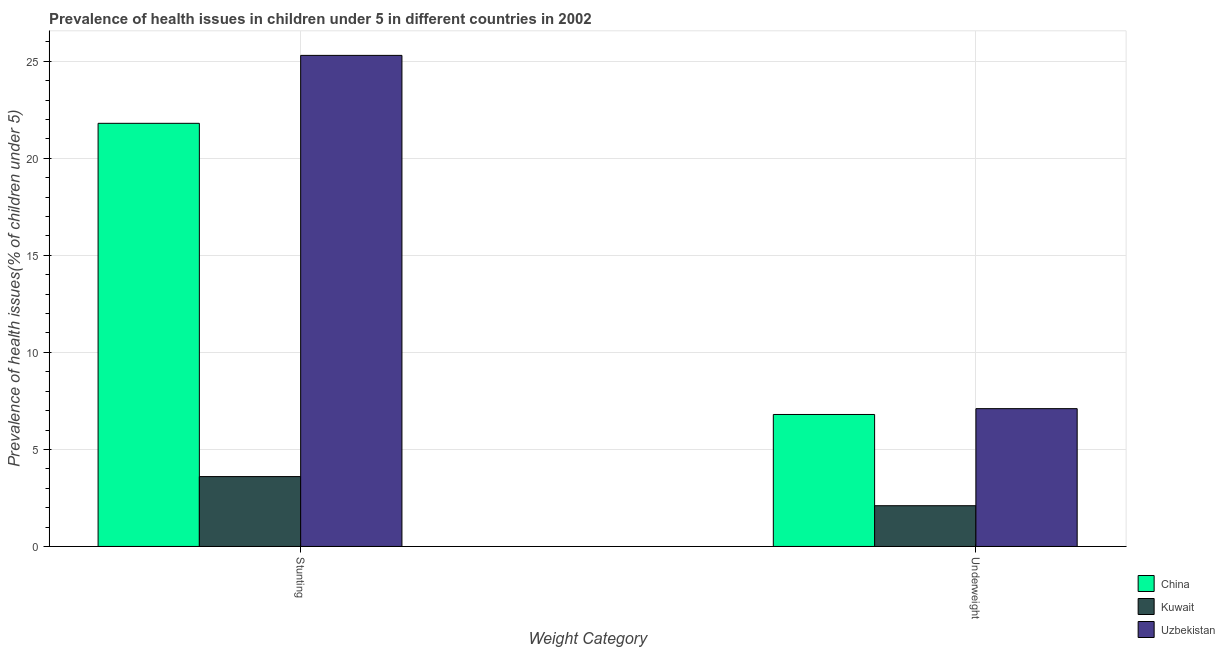Are the number of bars per tick equal to the number of legend labels?
Provide a succinct answer. Yes. Are the number of bars on each tick of the X-axis equal?
Provide a short and direct response. Yes. How many bars are there on the 1st tick from the left?
Offer a terse response. 3. What is the label of the 2nd group of bars from the left?
Keep it short and to the point. Underweight. What is the percentage of stunted children in Uzbekistan?
Your answer should be very brief. 25.3. Across all countries, what is the maximum percentage of underweight children?
Your answer should be compact. 7.1. Across all countries, what is the minimum percentage of underweight children?
Your answer should be very brief. 2.1. In which country was the percentage of stunted children maximum?
Give a very brief answer. Uzbekistan. In which country was the percentage of underweight children minimum?
Offer a terse response. Kuwait. What is the total percentage of stunted children in the graph?
Ensure brevity in your answer.  50.7. What is the difference between the percentage of stunted children in Uzbekistan and the percentage of underweight children in Kuwait?
Your answer should be very brief. 23.2. What is the average percentage of underweight children per country?
Ensure brevity in your answer.  5.33. What is the difference between the percentage of underweight children and percentage of stunted children in China?
Give a very brief answer. -15. In how many countries, is the percentage of stunted children greater than 23 %?
Give a very brief answer. 1. What is the ratio of the percentage of underweight children in Uzbekistan to that in China?
Your response must be concise. 1.04. In how many countries, is the percentage of stunted children greater than the average percentage of stunted children taken over all countries?
Give a very brief answer. 2. What does the 2nd bar from the left in Stunting represents?
Offer a very short reply. Kuwait. What does the 1st bar from the right in Underweight represents?
Offer a terse response. Uzbekistan. How many countries are there in the graph?
Offer a very short reply. 3. What is the difference between two consecutive major ticks on the Y-axis?
Offer a terse response. 5. Are the values on the major ticks of Y-axis written in scientific E-notation?
Offer a very short reply. No. Does the graph contain grids?
Your answer should be very brief. Yes. Where does the legend appear in the graph?
Give a very brief answer. Bottom right. How many legend labels are there?
Your answer should be very brief. 3. How are the legend labels stacked?
Provide a short and direct response. Vertical. What is the title of the graph?
Make the answer very short. Prevalence of health issues in children under 5 in different countries in 2002. Does "Botswana" appear as one of the legend labels in the graph?
Ensure brevity in your answer.  No. What is the label or title of the X-axis?
Keep it short and to the point. Weight Category. What is the label or title of the Y-axis?
Keep it short and to the point. Prevalence of health issues(% of children under 5). What is the Prevalence of health issues(% of children under 5) in China in Stunting?
Provide a succinct answer. 21.8. What is the Prevalence of health issues(% of children under 5) in Kuwait in Stunting?
Give a very brief answer. 3.6. What is the Prevalence of health issues(% of children under 5) in Uzbekistan in Stunting?
Your answer should be very brief. 25.3. What is the Prevalence of health issues(% of children under 5) of China in Underweight?
Provide a succinct answer. 6.8. What is the Prevalence of health issues(% of children under 5) of Kuwait in Underweight?
Offer a terse response. 2.1. What is the Prevalence of health issues(% of children under 5) in Uzbekistan in Underweight?
Offer a terse response. 7.1. Across all Weight Category, what is the maximum Prevalence of health issues(% of children under 5) of China?
Your response must be concise. 21.8. Across all Weight Category, what is the maximum Prevalence of health issues(% of children under 5) in Kuwait?
Offer a very short reply. 3.6. Across all Weight Category, what is the maximum Prevalence of health issues(% of children under 5) in Uzbekistan?
Provide a short and direct response. 25.3. Across all Weight Category, what is the minimum Prevalence of health issues(% of children under 5) in China?
Your answer should be compact. 6.8. Across all Weight Category, what is the minimum Prevalence of health issues(% of children under 5) in Kuwait?
Offer a terse response. 2.1. Across all Weight Category, what is the minimum Prevalence of health issues(% of children under 5) of Uzbekistan?
Your answer should be compact. 7.1. What is the total Prevalence of health issues(% of children under 5) of China in the graph?
Keep it short and to the point. 28.6. What is the total Prevalence of health issues(% of children under 5) in Kuwait in the graph?
Keep it short and to the point. 5.7. What is the total Prevalence of health issues(% of children under 5) in Uzbekistan in the graph?
Provide a succinct answer. 32.4. What is the difference between the Prevalence of health issues(% of children under 5) in Uzbekistan in Stunting and that in Underweight?
Provide a succinct answer. 18.2. What is the difference between the Prevalence of health issues(% of children under 5) of China in Stunting and the Prevalence of health issues(% of children under 5) of Kuwait in Underweight?
Provide a short and direct response. 19.7. What is the difference between the Prevalence of health issues(% of children under 5) in China in Stunting and the Prevalence of health issues(% of children under 5) in Uzbekistan in Underweight?
Keep it short and to the point. 14.7. What is the average Prevalence of health issues(% of children under 5) of Kuwait per Weight Category?
Your response must be concise. 2.85. What is the average Prevalence of health issues(% of children under 5) in Uzbekistan per Weight Category?
Offer a terse response. 16.2. What is the difference between the Prevalence of health issues(% of children under 5) of China and Prevalence of health issues(% of children under 5) of Uzbekistan in Stunting?
Your answer should be compact. -3.5. What is the difference between the Prevalence of health issues(% of children under 5) in Kuwait and Prevalence of health issues(% of children under 5) in Uzbekistan in Stunting?
Provide a succinct answer. -21.7. What is the difference between the Prevalence of health issues(% of children under 5) of China and Prevalence of health issues(% of children under 5) of Kuwait in Underweight?
Your response must be concise. 4.7. What is the difference between the Prevalence of health issues(% of children under 5) of China and Prevalence of health issues(% of children under 5) of Uzbekistan in Underweight?
Your answer should be compact. -0.3. What is the ratio of the Prevalence of health issues(% of children under 5) of China in Stunting to that in Underweight?
Offer a terse response. 3.21. What is the ratio of the Prevalence of health issues(% of children under 5) of Kuwait in Stunting to that in Underweight?
Make the answer very short. 1.71. What is the ratio of the Prevalence of health issues(% of children under 5) in Uzbekistan in Stunting to that in Underweight?
Your answer should be compact. 3.56. What is the difference between the highest and the second highest Prevalence of health issues(% of children under 5) of Uzbekistan?
Make the answer very short. 18.2. 